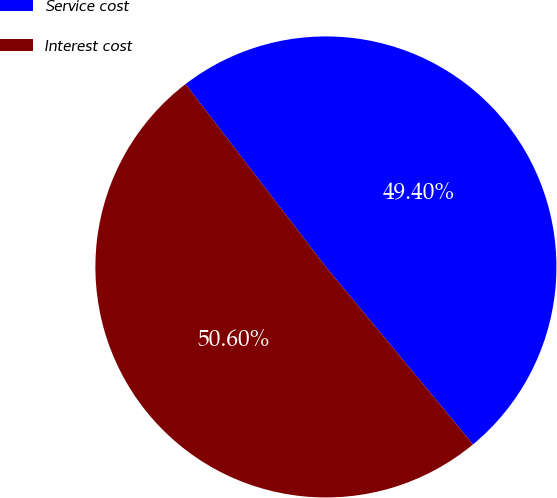Convert chart to OTSL. <chart><loc_0><loc_0><loc_500><loc_500><pie_chart><fcel>Service cost<fcel>Interest cost<nl><fcel>49.4%<fcel>50.6%<nl></chart> 